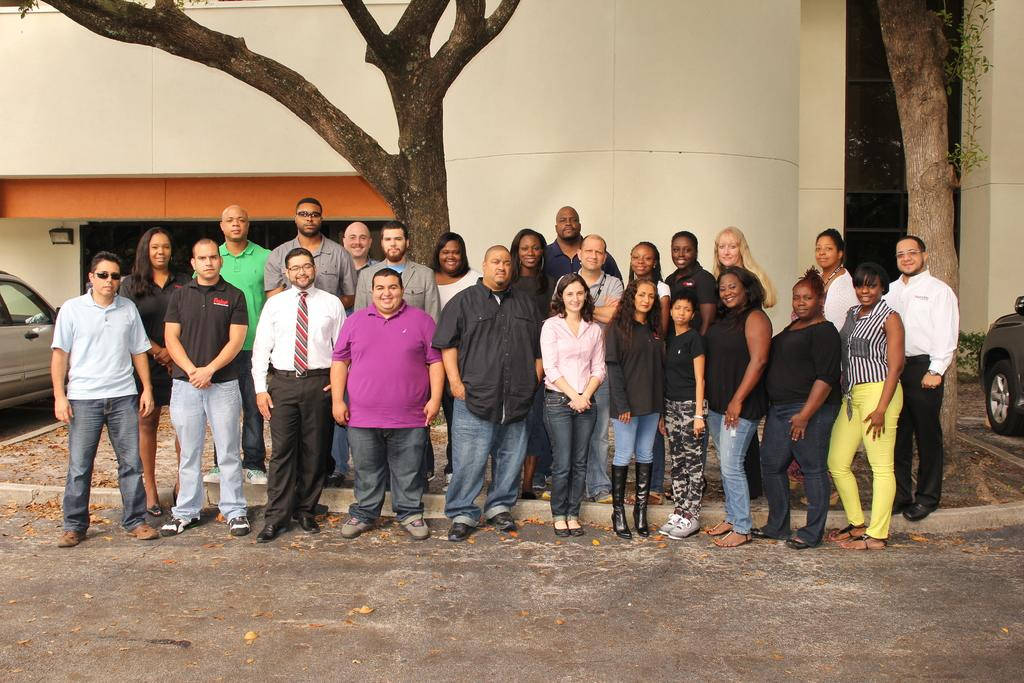How many people are in the image? There are many women and men in the image. Where are the people located in the image? They are standing on the side of the road. What can be seen in the background of the image? There is a tree and a building in the image. What is on the left side of the image? There is a car on the left side of the image. What type of oatmeal is being served to the people in the image? There is no oatmeal present in the image; the people are standing on the side of the road. What grade level are the people in the image? There is no indication of grade level in the image; it only shows people standing on the side of the road. 